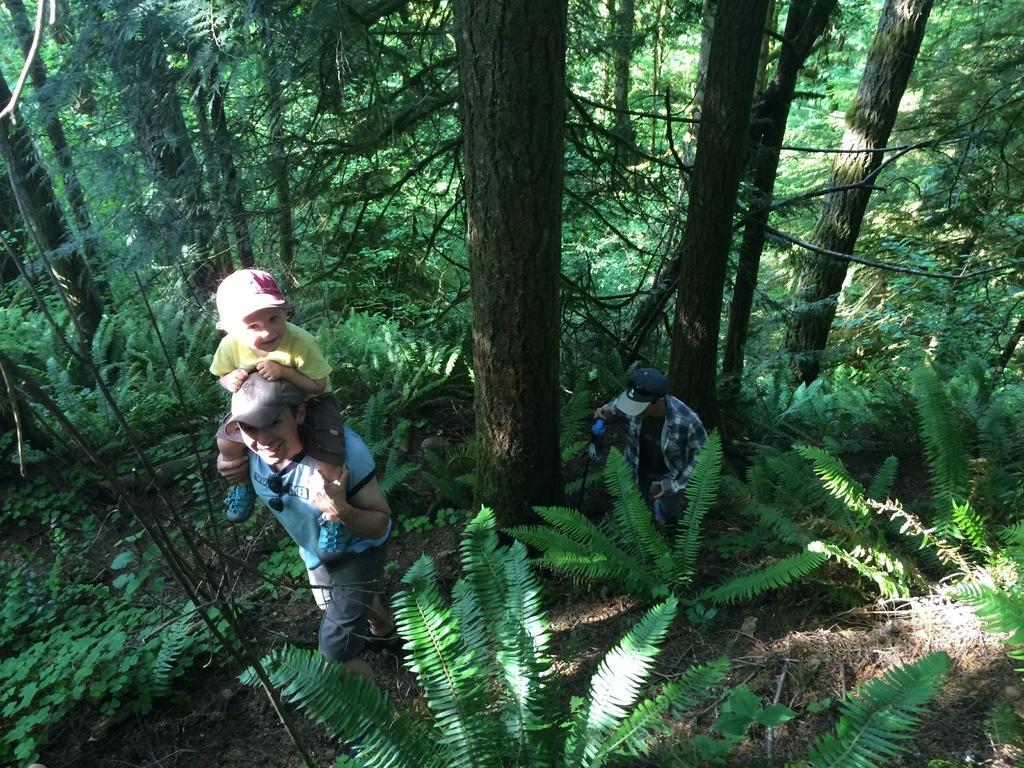Could you give a brief overview of what you see in this image? In this image I can see number of trees, number of plants and two persons in the front. I can also see a boy is sitting on the shoulders of one person. 